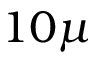<formula> <loc_0><loc_0><loc_500><loc_500>1 0 \mu</formula> 